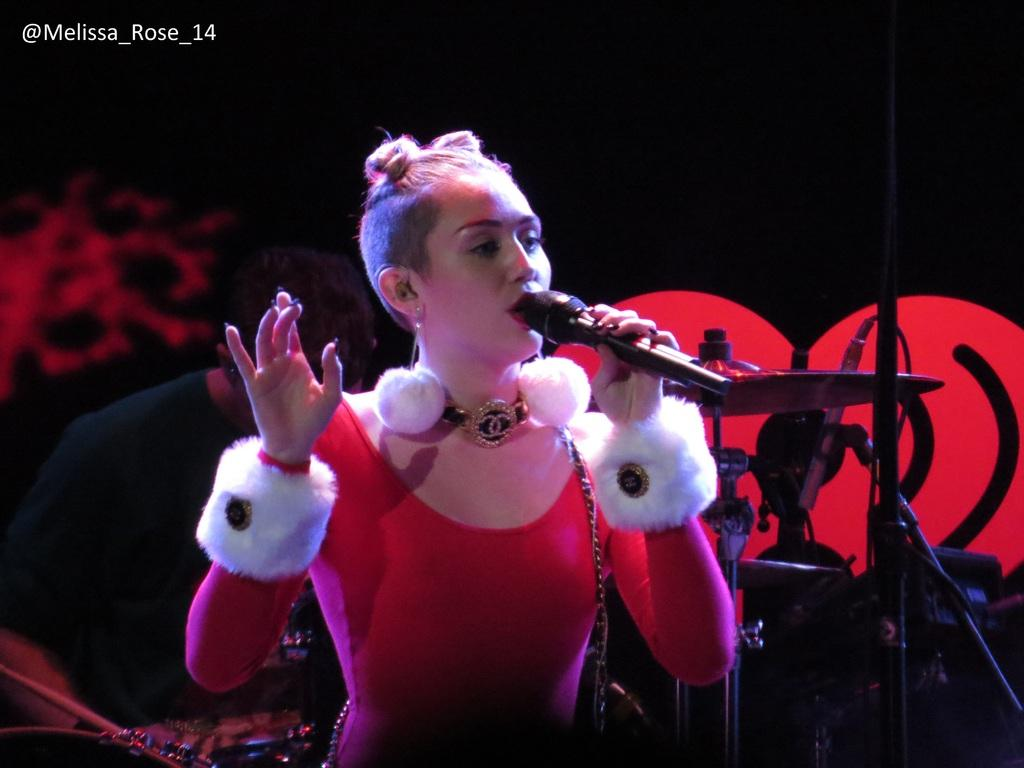Who is the main subject in the image? There is a woman in the image. What is the woman wearing? The woman is wearing a red dress. What is the woman holding in the image? The woman is holding a microphone. What is the color of the background in the image? The background of the image is dark. What type of nut is being used for the treatment in the image? There is no nut or treatment present in the image; it features a woman holding a microphone with a dark background. Can you tell me how many boys are visible in the image? There are no boys present in the image; it features a woman holding a microphone with a dark background. 